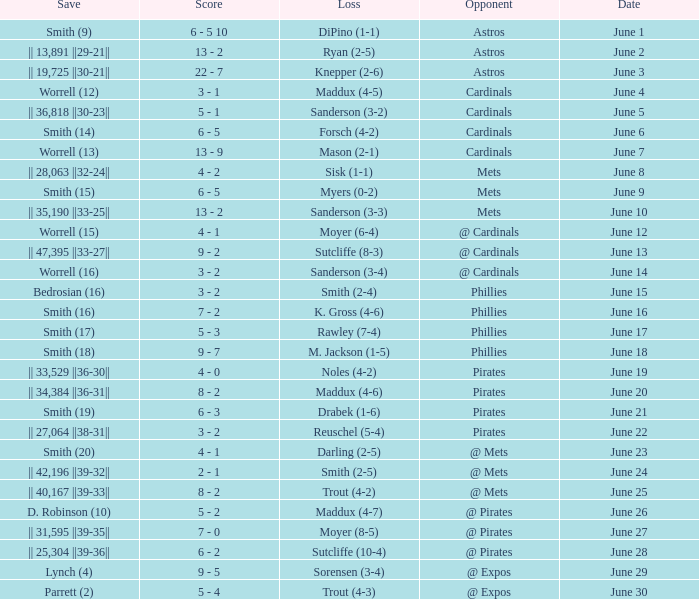On which day did the Chicago Cubs have a loss of trout (4-2)? June 25. 